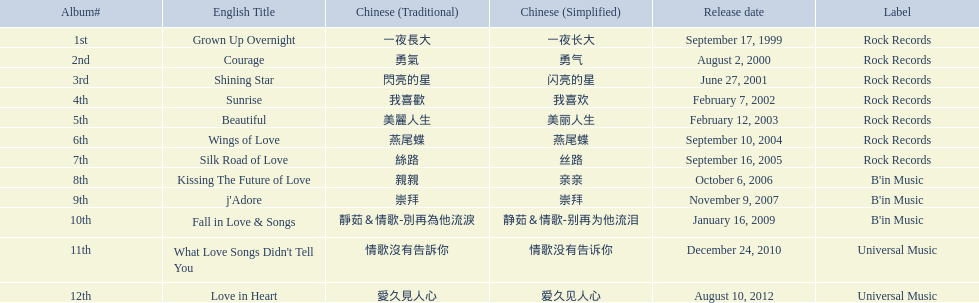Which album was released later, beautiful, or j'adore? J'adore. 